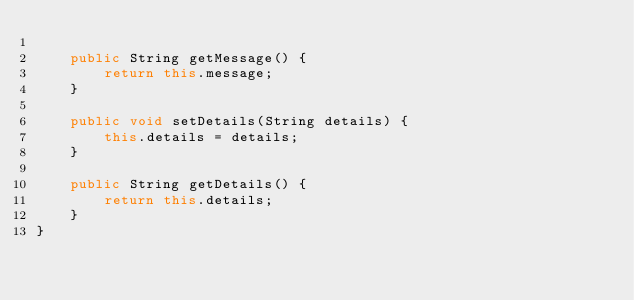<code> <loc_0><loc_0><loc_500><loc_500><_Java_>
    public String getMessage() {
        return this.message;
    }

    public void setDetails(String details) {
        this.details = details;
    }

    public String getDetails() {
        return this.details;
    }
}
</code> 